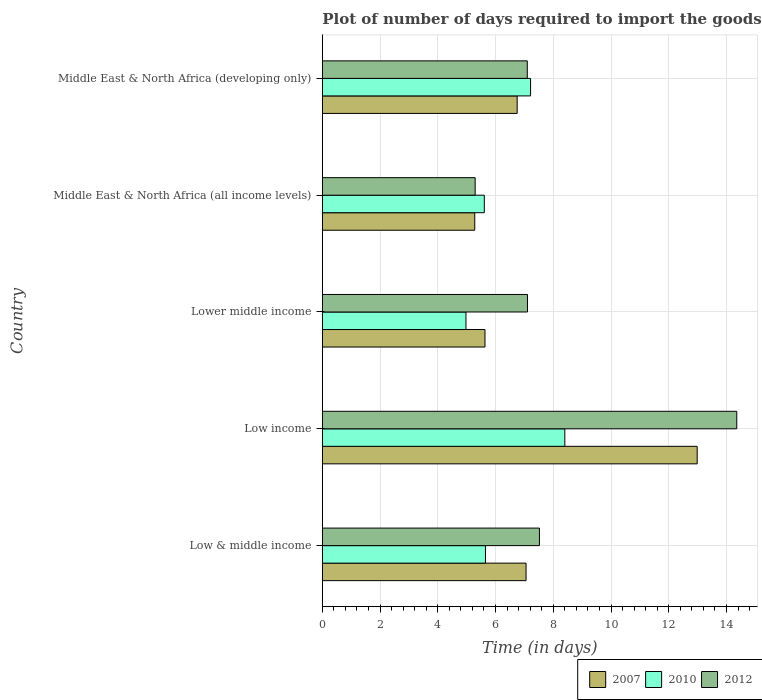How many bars are there on the 4th tick from the top?
Offer a very short reply. 3. How many bars are there on the 4th tick from the bottom?
Offer a very short reply. 3. What is the label of the 1st group of bars from the top?
Ensure brevity in your answer.  Middle East & North Africa (developing only). In how many cases, is the number of bars for a given country not equal to the number of legend labels?
Offer a very short reply. 0. What is the time required to import goods in 2007 in Lower middle income?
Keep it short and to the point. 5.63. Across all countries, what is the maximum time required to import goods in 2012?
Keep it short and to the point. 14.36. Across all countries, what is the minimum time required to import goods in 2012?
Ensure brevity in your answer.  5.29. In which country was the time required to import goods in 2007 maximum?
Offer a terse response. Low income. In which country was the time required to import goods in 2007 minimum?
Your answer should be compact. Middle East & North Africa (all income levels). What is the total time required to import goods in 2012 in the graph?
Offer a very short reply. 41.38. What is the difference between the time required to import goods in 2012 in Low & middle income and that in Middle East & North Africa (all income levels)?
Your response must be concise. 2.23. What is the difference between the time required to import goods in 2010 in Lower middle income and the time required to import goods in 2007 in Middle East & North Africa (developing only)?
Provide a short and direct response. -1.77. What is the average time required to import goods in 2007 per country?
Provide a short and direct response. 7.54. What is the difference between the time required to import goods in 2010 and time required to import goods in 2007 in Low & middle income?
Provide a short and direct response. -1.41. What is the ratio of the time required to import goods in 2010 in Low & middle income to that in Middle East & North Africa (all income levels)?
Make the answer very short. 1.01. Is the time required to import goods in 2010 in Low income less than that in Lower middle income?
Your response must be concise. No. Is the difference between the time required to import goods in 2010 in Low & middle income and Middle East & North Africa (all income levels) greater than the difference between the time required to import goods in 2007 in Low & middle income and Middle East & North Africa (all income levels)?
Keep it short and to the point. No. What is the difference between the highest and the second highest time required to import goods in 2007?
Your answer should be compact. 5.93. What is the difference between the highest and the lowest time required to import goods in 2012?
Your answer should be compact. 9.06. What does the 3rd bar from the top in Middle East & North Africa (developing only) represents?
Give a very brief answer. 2007. What does the 2nd bar from the bottom in Middle East & North Africa (developing only) represents?
Keep it short and to the point. 2010. Is it the case that in every country, the sum of the time required to import goods in 2010 and time required to import goods in 2012 is greater than the time required to import goods in 2007?
Offer a very short reply. Yes. Are all the bars in the graph horizontal?
Your answer should be very brief. Yes. Does the graph contain any zero values?
Your answer should be compact. No. Does the graph contain grids?
Give a very brief answer. Yes. What is the title of the graph?
Your answer should be very brief. Plot of number of days required to import the goods. Does "1962" appear as one of the legend labels in the graph?
Provide a succinct answer. No. What is the label or title of the X-axis?
Provide a short and direct response. Time (in days). What is the Time (in days) in 2007 in Low & middle income?
Your answer should be very brief. 7.06. What is the Time (in days) of 2010 in Low & middle income?
Ensure brevity in your answer.  5.65. What is the Time (in days) in 2012 in Low & middle income?
Offer a very short reply. 7.52. What is the Time (in days) of 2007 in Low income?
Offer a terse response. 12.99. What is the Time (in days) in 2010 in Low income?
Your answer should be compact. 8.4. What is the Time (in days) of 2012 in Low income?
Your answer should be compact. 14.36. What is the Time (in days) in 2007 in Lower middle income?
Provide a succinct answer. 5.63. What is the Time (in days) of 2010 in Lower middle income?
Make the answer very short. 4.98. What is the Time (in days) of 2012 in Lower middle income?
Give a very brief answer. 7.11. What is the Time (in days) in 2007 in Middle East & North Africa (all income levels)?
Keep it short and to the point. 5.28. What is the Time (in days) of 2010 in Middle East & North Africa (all income levels)?
Your answer should be very brief. 5.61. What is the Time (in days) in 2012 in Middle East & North Africa (all income levels)?
Your response must be concise. 5.29. What is the Time (in days) in 2007 in Middle East & North Africa (developing only)?
Ensure brevity in your answer.  6.75. What is the Time (in days) of 2010 in Middle East & North Africa (developing only)?
Your answer should be compact. 7.21. What is the Time (in days) of 2012 in Middle East & North Africa (developing only)?
Give a very brief answer. 7.1. Across all countries, what is the maximum Time (in days) of 2007?
Make the answer very short. 12.99. Across all countries, what is the maximum Time (in days) of 2010?
Provide a succinct answer. 8.4. Across all countries, what is the maximum Time (in days) in 2012?
Make the answer very short. 14.36. Across all countries, what is the minimum Time (in days) in 2007?
Provide a short and direct response. 5.28. Across all countries, what is the minimum Time (in days) in 2010?
Your answer should be very brief. 4.98. Across all countries, what is the minimum Time (in days) in 2012?
Provide a succinct answer. 5.29. What is the total Time (in days) of 2007 in the graph?
Make the answer very short. 37.71. What is the total Time (in days) in 2010 in the graph?
Make the answer very short. 31.85. What is the total Time (in days) of 2012 in the graph?
Your answer should be compact. 41.38. What is the difference between the Time (in days) of 2007 in Low & middle income and that in Low income?
Ensure brevity in your answer.  -5.93. What is the difference between the Time (in days) of 2010 in Low & middle income and that in Low income?
Give a very brief answer. -2.75. What is the difference between the Time (in days) in 2012 in Low & middle income and that in Low income?
Your answer should be very brief. -6.84. What is the difference between the Time (in days) in 2007 in Low & middle income and that in Lower middle income?
Give a very brief answer. 1.42. What is the difference between the Time (in days) in 2010 in Low & middle income and that in Lower middle income?
Your response must be concise. 0.68. What is the difference between the Time (in days) of 2012 in Low & middle income and that in Lower middle income?
Provide a short and direct response. 0.41. What is the difference between the Time (in days) in 2007 in Low & middle income and that in Middle East & North Africa (all income levels)?
Offer a very short reply. 1.78. What is the difference between the Time (in days) of 2010 in Low & middle income and that in Middle East & North Africa (all income levels)?
Keep it short and to the point. 0.04. What is the difference between the Time (in days) in 2012 in Low & middle income and that in Middle East & North Africa (all income levels)?
Offer a very short reply. 2.23. What is the difference between the Time (in days) in 2007 in Low & middle income and that in Middle East & North Africa (developing only)?
Your answer should be very brief. 0.31. What is the difference between the Time (in days) of 2010 in Low & middle income and that in Middle East & North Africa (developing only)?
Keep it short and to the point. -1.56. What is the difference between the Time (in days) of 2012 in Low & middle income and that in Middle East & North Africa (developing only)?
Your answer should be compact. 0.42. What is the difference between the Time (in days) in 2007 in Low income and that in Lower middle income?
Your answer should be very brief. 7.35. What is the difference between the Time (in days) of 2010 in Low income and that in Lower middle income?
Provide a short and direct response. 3.42. What is the difference between the Time (in days) of 2012 in Low income and that in Lower middle income?
Provide a short and direct response. 7.25. What is the difference between the Time (in days) in 2007 in Low income and that in Middle East & North Africa (all income levels)?
Offer a terse response. 7.71. What is the difference between the Time (in days) of 2010 in Low income and that in Middle East & North Africa (all income levels)?
Make the answer very short. 2.79. What is the difference between the Time (in days) of 2012 in Low income and that in Middle East & North Africa (all income levels)?
Provide a succinct answer. 9.06. What is the difference between the Time (in days) in 2007 in Low income and that in Middle East & North Africa (developing only)?
Give a very brief answer. 6.24. What is the difference between the Time (in days) of 2010 in Low income and that in Middle East & North Africa (developing only)?
Provide a short and direct response. 1.19. What is the difference between the Time (in days) in 2012 in Low income and that in Middle East & North Africa (developing only)?
Offer a very short reply. 7.26. What is the difference between the Time (in days) in 2007 in Lower middle income and that in Middle East & North Africa (all income levels)?
Make the answer very short. 0.35. What is the difference between the Time (in days) in 2010 in Lower middle income and that in Middle East & North Africa (all income levels)?
Keep it short and to the point. -0.64. What is the difference between the Time (in days) in 2012 in Lower middle income and that in Middle East & North Africa (all income levels)?
Ensure brevity in your answer.  1.81. What is the difference between the Time (in days) of 2007 in Lower middle income and that in Middle East & North Africa (developing only)?
Give a very brief answer. -1.11. What is the difference between the Time (in days) of 2010 in Lower middle income and that in Middle East & North Africa (developing only)?
Offer a very short reply. -2.24. What is the difference between the Time (in days) of 2012 in Lower middle income and that in Middle East & North Africa (developing only)?
Give a very brief answer. 0.01. What is the difference between the Time (in days) in 2007 in Middle East & North Africa (all income levels) and that in Middle East & North Africa (developing only)?
Make the answer very short. -1.47. What is the difference between the Time (in days) of 2010 in Middle East & North Africa (all income levels) and that in Middle East & North Africa (developing only)?
Provide a short and direct response. -1.6. What is the difference between the Time (in days) of 2012 in Middle East & North Africa (all income levels) and that in Middle East & North Africa (developing only)?
Make the answer very short. -1.81. What is the difference between the Time (in days) in 2007 in Low & middle income and the Time (in days) in 2010 in Low income?
Your answer should be compact. -1.34. What is the difference between the Time (in days) in 2007 in Low & middle income and the Time (in days) in 2012 in Low income?
Provide a succinct answer. -7.3. What is the difference between the Time (in days) in 2010 in Low & middle income and the Time (in days) in 2012 in Low income?
Your answer should be compact. -8.71. What is the difference between the Time (in days) in 2007 in Low & middle income and the Time (in days) in 2010 in Lower middle income?
Make the answer very short. 2.08. What is the difference between the Time (in days) of 2007 in Low & middle income and the Time (in days) of 2012 in Lower middle income?
Ensure brevity in your answer.  -0.05. What is the difference between the Time (in days) in 2010 in Low & middle income and the Time (in days) in 2012 in Lower middle income?
Give a very brief answer. -1.46. What is the difference between the Time (in days) in 2007 in Low & middle income and the Time (in days) in 2010 in Middle East & North Africa (all income levels)?
Provide a succinct answer. 1.45. What is the difference between the Time (in days) in 2007 in Low & middle income and the Time (in days) in 2012 in Middle East & North Africa (all income levels)?
Your response must be concise. 1.76. What is the difference between the Time (in days) in 2010 in Low & middle income and the Time (in days) in 2012 in Middle East & North Africa (all income levels)?
Ensure brevity in your answer.  0.36. What is the difference between the Time (in days) of 2007 in Low & middle income and the Time (in days) of 2010 in Middle East & North Africa (developing only)?
Make the answer very short. -0.16. What is the difference between the Time (in days) of 2007 in Low & middle income and the Time (in days) of 2012 in Middle East & North Africa (developing only)?
Provide a short and direct response. -0.04. What is the difference between the Time (in days) of 2010 in Low & middle income and the Time (in days) of 2012 in Middle East & North Africa (developing only)?
Offer a very short reply. -1.45. What is the difference between the Time (in days) in 2007 in Low income and the Time (in days) in 2010 in Lower middle income?
Offer a very short reply. 8.01. What is the difference between the Time (in days) in 2007 in Low income and the Time (in days) in 2012 in Lower middle income?
Provide a succinct answer. 5.88. What is the difference between the Time (in days) of 2010 in Low income and the Time (in days) of 2012 in Lower middle income?
Offer a very short reply. 1.29. What is the difference between the Time (in days) of 2007 in Low income and the Time (in days) of 2010 in Middle East & North Africa (all income levels)?
Your response must be concise. 7.37. What is the difference between the Time (in days) of 2007 in Low income and the Time (in days) of 2012 in Middle East & North Africa (all income levels)?
Your response must be concise. 7.69. What is the difference between the Time (in days) in 2010 in Low income and the Time (in days) in 2012 in Middle East & North Africa (all income levels)?
Provide a succinct answer. 3.11. What is the difference between the Time (in days) in 2007 in Low income and the Time (in days) in 2010 in Middle East & North Africa (developing only)?
Make the answer very short. 5.77. What is the difference between the Time (in days) of 2007 in Low income and the Time (in days) of 2012 in Middle East & North Africa (developing only)?
Offer a very short reply. 5.89. What is the difference between the Time (in days) in 2010 in Low income and the Time (in days) in 2012 in Middle East & North Africa (developing only)?
Your response must be concise. 1.3. What is the difference between the Time (in days) of 2007 in Lower middle income and the Time (in days) of 2010 in Middle East & North Africa (all income levels)?
Offer a very short reply. 0.02. What is the difference between the Time (in days) of 2007 in Lower middle income and the Time (in days) of 2012 in Middle East & North Africa (all income levels)?
Your answer should be very brief. 0.34. What is the difference between the Time (in days) in 2010 in Lower middle income and the Time (in days) in 2012 in Middle East & North Africa (all income levels)?
Your response must be concise. -0.32. What is the difference between the Time (in days) in 2007 in Lower middle income and the Time (in days) in 2010 in Middle East & North Africa (developing only)?
Your answer should be very brief. -1.58. What is the difference between the Time (in days) of 2007 in Lower middle income and the Time (in days) of 2012 in Middle East & North Africa (developing only)?
Provide a succinct answer. -1.47. What is the difference between the Time (in days) of 2010 in Lower middle income and the Time (in days) of 2012 in Middle East & North Africa (developing only)?
Make the answer very short. -2.12. What is the difference between the Time (in days) in 2007 in Middle East & North Africa (all income levels) and the Time (in days) in 2010 in Middle East & North Africa (developing only)?
Provide a succinct answer. -1.93. What is the difference between the Time (in days) in 2007 in Middle East & North Africa (all income levels) and the Time (in days) in 2012 in Middle East & North Africa (developing only)?
Offer a very short reply. -1.82. What is the difference between the Time (in days) of 2010 in Middle East & North Africa (all income levels) and the Time (in days) of 2012 in Middle East & North Africa (developing only)?
Your answer should be very brief. -1.49. What is the average Time (in days) of 2007 per country?
Make the answer very short. 7.54. What is the average Time (in days) of 2010 per country?
Make the answer very short. 6.37. What is the average Time (in days) in 2012 per country?
Give a very brief answer. 8.28. What is the difference between the Time (in days) of 2007 and Time (in days) of 2010 in Low & middle income?
Provide a succinct answer. 1.41. What is the difference between the Time (in days) in 2007 and Time (in days) in 2012 in Low & middle income?
Ensure brevity in your answer.  -0.46. What is the difference between the Time (in days) in 2010 and Time (in days) in 2012 in Low & middle income?
Give a very brief answer. -1.87. What is the difference between the Time (in days) in 2007 and Time (in days) in 2010 in Low income?
Keep it short and to the point. 4.58. What is the difference between the Time (in days) in 2007 and Time (in days) in 2012 in Low income?
Provide a succinct answer. -1.37. What is the difference between the Time (in days) of 2010 and Time (in days) of 2012 in Low income?
Provide a succinct answer. -5.96. What is the difference between the Time (in days) of 2007 and Time (in days) of 2010 in Lower middle income?
Offer a very short reply. 0.66. What is the difference between the Time (in days) in 2007 and Time (in days) in 2012 in Lower middle income?
Give a very brief answer. -1.47. What is the difference between the Time (in days) in 2010 and Time (in days) in 2012 in Lower middle income?
Provide a succinct answer. -2.13. What is the difference between the Time (in days) of 2007 and Time (in days) of 2010 in Middle East & North Africa (all income levels)?
Offer a terse response. -0.33. What is the difference between the Time (in days) in 2007 and Time (in days) in 2012 in Middle East & North Africa (all income levels)?
Give a very brief answer. -0.01. What is the difference between the Time (in days) of 2010 and Time (in days) of 2012 in Middle East & North Africa (all income levels)?
Your response must be concise. 0.32. What is the difference between the Time (in days) in 2007 and Time (in days) in 2010 in Middle East & North Africa (developing only)?
Offer a very short reply. -0.46. What is the difference between the Time (in days) of 2007 and Time (in days) of 2012 in Middle East & North Africa (developing only)?
Offer a terse response. -0.35. What is the difference between the Time (in days) in 2010 and Time (in days) in 2012 in Middle East & North Africa (developing only)?
Give a very brief answer. 0.11. What is the ratio of the Time (in days) of 2007 in Low & middle income to that in Low income?
Offer a very short reply. 0.54. What is the ratio of the Time (in days) of 2010 in Low & middle income to that in Low income?
Your answer should be compact. 0.67. What is the ratio of the Time (in days) of 2012 in Low & middle income to that in Low income?
Make the answer very short. 0.52. What is the ratio of the Time (in days) in 2007 in Low & middle income to that in Lower middle income?
Ensure brevity in your answer.  1.25. What is the ratio of the Time (in days) of 2010 in Low & middle income to that in Lower middle income?
Offer a terse response. 1.14. What is the ratio of the Time (in days) of 2012 in Low & middle income to that in Lower middle income?
Make the answer very short. 1.06. What is the ratio of the Time (in days) in 2007 in Low & middle income to that in Middle East & North Africa (all income levels)?
Provide a succinct answer. 1.34. What is the ratio of the Time (in days) in 2010 in Low & middle income to that in Middle East & North Africa (all income levels)?
Make the answer very short. 1.01. What is the ratio of the Time (in days) of 2012 in Low & middle income to that in Middle East & North Africa (all income levels)?
Your answer should be compact. 1.42. What is the ratio of the Time (in days) of 2007 in Low & middle income to that in Middle East & North Africa (developing only)?
Keep it short and to the point. 1.05. What is the ratio of the Time (in days) of 2010 in Low & middle income to that in Middle East & North Africa (developing only)?
Ensure brevity in your answer.  0.78. What is the ratio of the Time (in days) in 2012 in Low & middle income to that in Middle East & North Africa (developing only)?
Give a very brief answer. 1.06. What is the ratio of the Time (in days) in 2007 in Low income to that in Lower middle income?
Provide a succinct answer. 2.3. What is the ratio of the Time (in days) of 2010 in Low income to that in Lower middle income?
Make the answer very short. 1.69. What is the ratio of the Time (in days) of 2012 in Low income to that in Lower middle income?
Ensure brevity in your answer.  2.02. What is the ratio of the Time (in days) in 2007 in Low income to that in Middle East & North Africa (all income levels)?
Ensure brevity in your answer.  2.46. What is the ratio of the Time (in days) of 2010 in Low income to that in Middle East & North Africa (all income levels)?
Make the answer very short. 1.5. What is the ratio of the Time (in days) of 2012 in Low income to that in Middle East & North Africa (all income levels)?
Provide a succinct answer. 2.71. What is the ratio of the Time (in days) of 2007 in Low income to that in Middle East & North Africa (developing only)?
Make the answer very short. 1.92. What is the ratio of the Time (in days) of 2010 in Low income to that in Middle East & North Africa (developing only)?
Give a very brief answer. 1.16. What is the ratio of the Time (in days) of 2012 in Low income to that in Middle East & North Africa (developing only)?
Keep it short and to the point. 2.02. What is the ratio of the Time (in days) of 2007 in Lower middle income to that in Middle East & North Africa (all income levels)?
Make the answer very short. 1.07. What is the ratio of the Time (in days) of 2010 in Lower middle income to that in Middle East & North Africa (all income levels)?
Your response must be concise. 0.89. What is the ratio of the Time (in days) in 2012 in Lower middle income to that in Middle East & North Africa (all income levels)?
Ensure brevity in your answer.  1.34. What is the ratio of the Time (in days) of 2007 in Lower middle income to that in Middle East & North Africa (developing only)?
Provide a short and direct response. 0.83. What is the ratio of the Time (in days) in 2010 in Lower middle income to that in Middle East & North Africa (developing only)?
Offer a terse response. 0.69. What is the ratio of the Time (in days) of 2007 in Middle East & North Africa (all income levels) to that in Middle East & North Africa (developing only)?
Provide a short and direct response. 0.78. What is the ratio of the Time (in days) in 2010 in Middle East & North Africa (all income levels) to that in Middle East & North Africa (developing only)?
Keep it short and to the point. 0.78. What is the ratio of the Time (in days) in 2012 in Middle East & North Africa (all income levels) to that in Middle East & North Africa (developing only)?
Ensure brevity in your answer.  0.75. What is the difference between the highest and the second highest Time (in days) of 2007?
Offer a terse response. 5.93. What is the difference between the highest and the second highest Time (in days) of 2010?
Offer a very short reply. 1.19. What is the difference between the highest and the second highest Time (in days) of 2012?
Your response must be concise. 6.84. What is the difference between the highest and the lowest Time (in days) in 2007?
Keep it short and to the point. 7.71. What is the difference between the highest and the lowest Time (in days) in 2010?
Your response must be concise. 3.42. What is the difference between the highest and the lowest Time (in days) in 2012?
Keep it short and to the point. 9.06. 